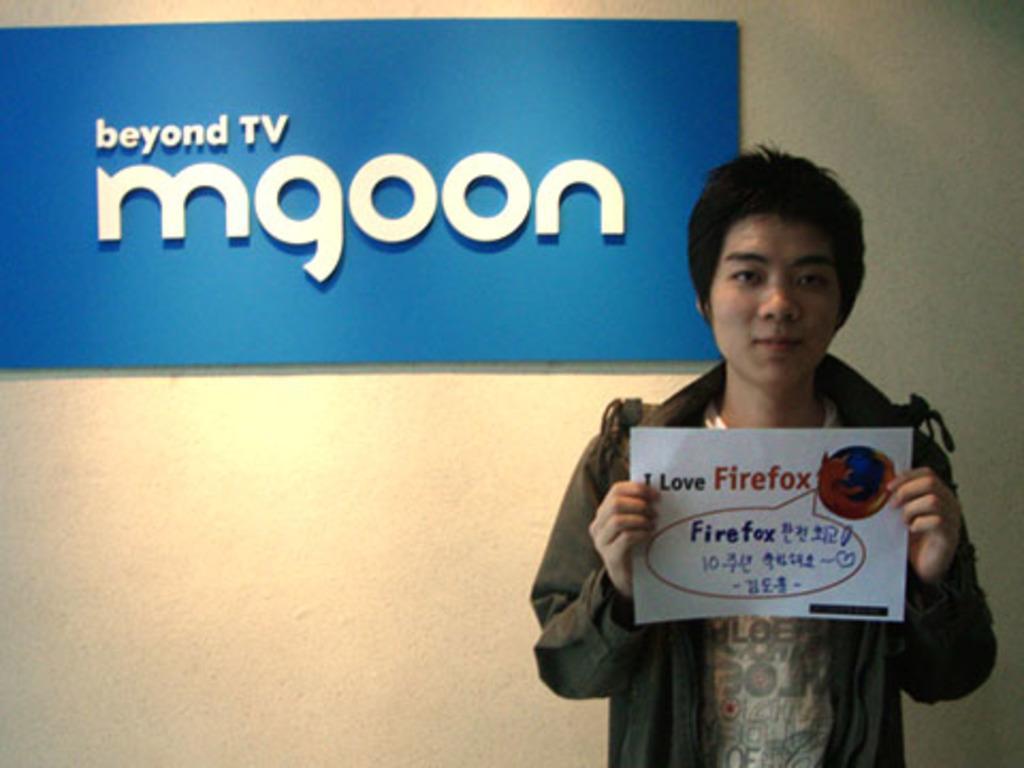Describe this image in one or two sentences. In this image we can see a person standing and holding a poster. In the background there is a wall and we can see a board. 